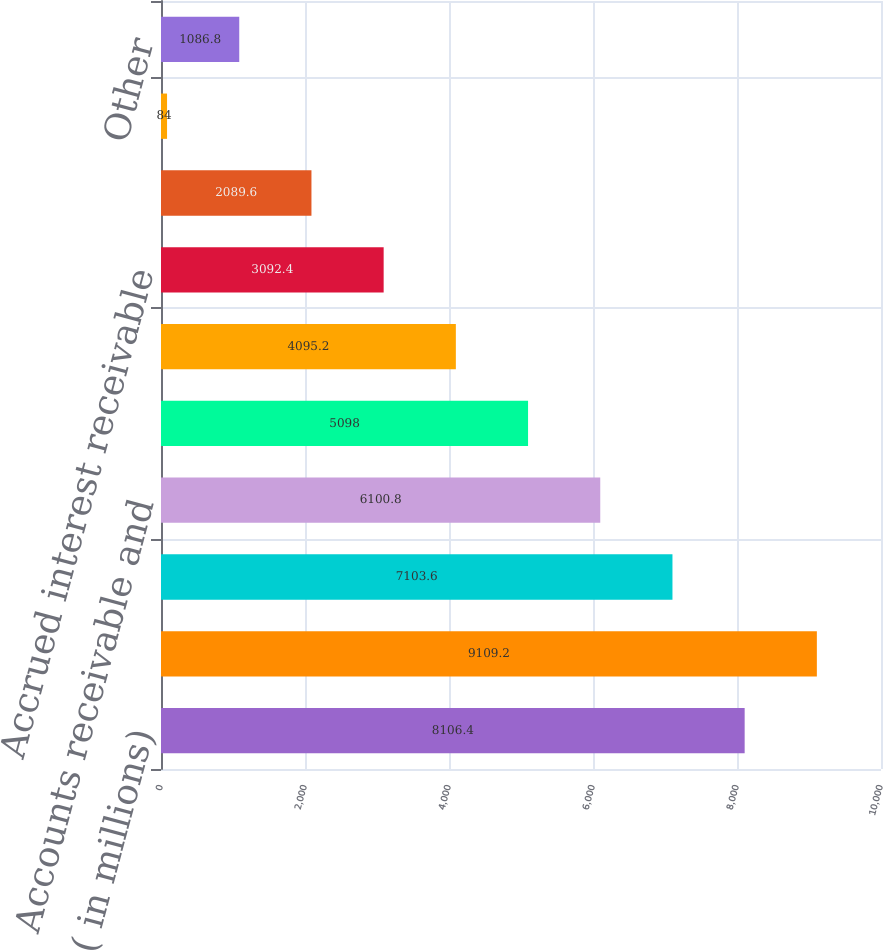Convert chart to OTSL. <chart><loc_0><loc_0><loc_500><loc_500><bar_chart><fcel>( in millions)<fcel>Derivative instruments<fcel>Bank owned life insurance<fcel>Accounts receivable and<fcel>Partnership investments<fcel>Deposit with IRS<fcel>Accrued interest receivable<fcel>Other real estate owned<fcel>Prepaid pension and other<fcel>Other<nl><fcel>8106.4<fcel>9109.2<fcel>7103.6<fcel>6100.8<fcel>5098<fcel>4095.2<fcel>3092.4<fcel>2089.6<fcel>84<fcel>1086.8<nl></chart> 